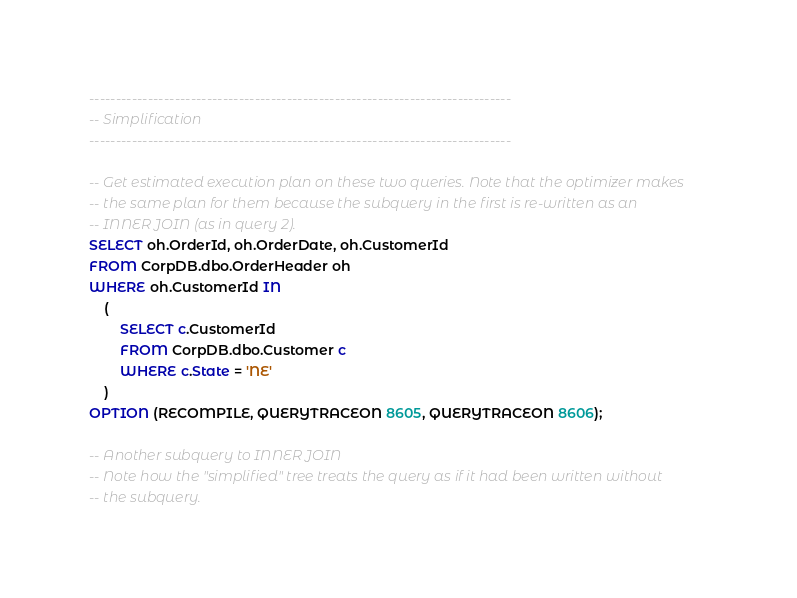<code> <loc_0><loc_0><loc_500><loc_500><_SQL_>-------------------------------------------------------------------------------
-- Simplification
-------------------------------------------------------------------------------

-- Get estimated execution plan on these two queries. Note that the optimizer makes 
-- the same plan for them because the subquery in the first is re-written as an 
-- INNER JOIN (as in query 2).
SELECT oh.OrderId, oh.OrderDate, oh.CustomerId
FROM CorpDB.dbo.OrderHeader oh
WHERE oh.CustomerId IN
	(
		SELECT c.CustomerId
		FROM CorpDB.dbo.Customer c
		WHERE c.State = 'NE'
	)
OPTION (RECOMPILE, QUERYTRACEON 8605, QUERYTRACEON 8606);

-- Another subquery to INNER JOIN
-- Note how the "simplified" tree treats the query as if it had been written without 
-- the subquery.</code> 